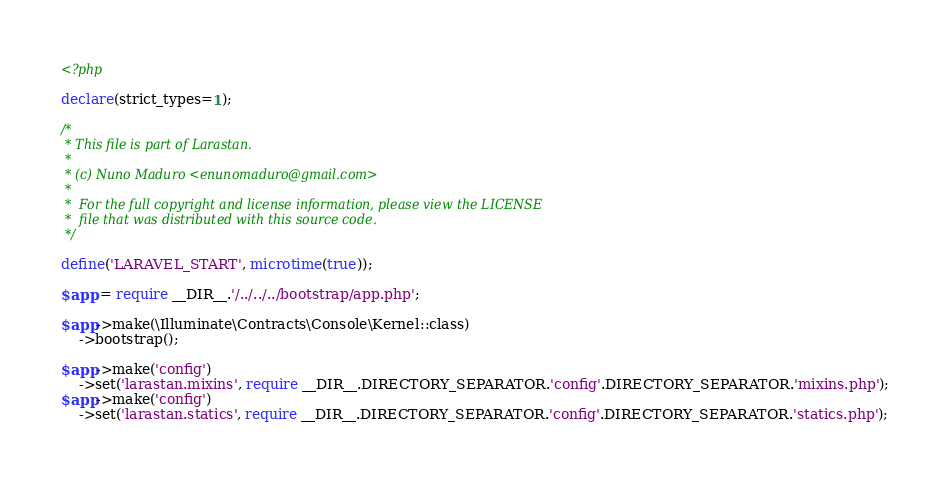<code> <loc_0><loc_0><loc_500><loc_500><_PHP_><?php

declare(strict_types=1);

/*
 * This file is part of Larastan.
 *
 * (c) Nuno Maduro <enunomaduro@gmail.com>
 *
 *  For the full copyright and license information, please view the LICENSE
 *  file that was distributed with this source code.
 */

define('LARAVEL_START', microtime(true));

$app = require __DIR__.'/../../../bootstrap/app.php';

$app->make(\Illuminate\Contracts\Console\Kernel::class)
    ->bootstrap();

$app->make('config')
    ->set('larastan.mixins', require __DIR__.DIRECTORY_SEPARATOR.'config'.DIRECTORY_SEPARATOR.'mixins.php');
$app->make('config')
    ->set('larastan.statics', require __DIR__.DIRECTORY_SEPARATOR.'config'.DIRECTORY_SEPARATOR.'statics.php');
</code> 